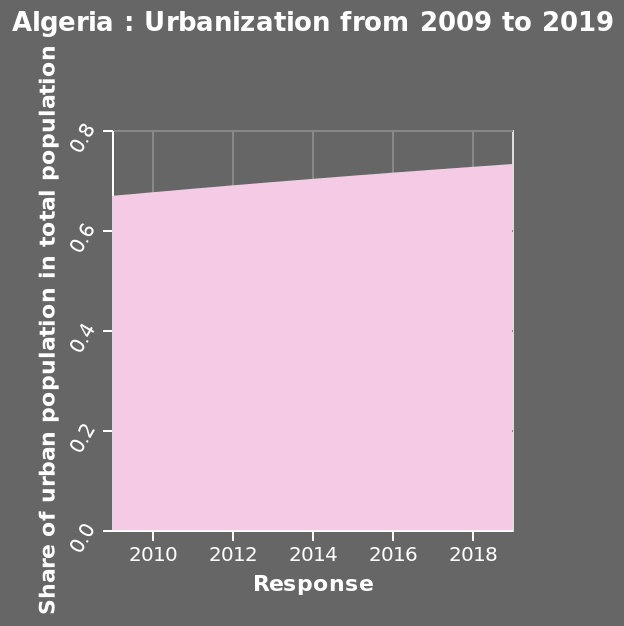<image>
What is the current value of the mentioned trend? The current value of the trend is approximately 0.75. 